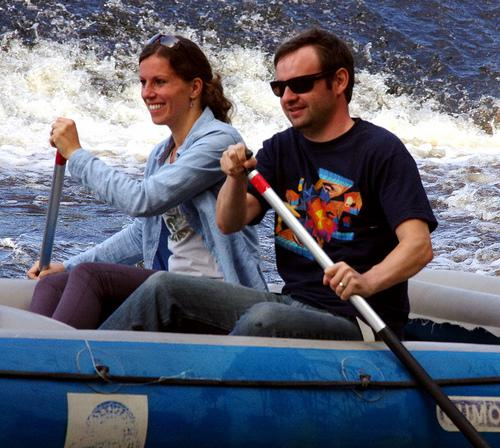Question: what keeps them afloat?
Choices:
A. Gravity.
B. Buoyancy.
C. Determination.
D. A boat.
Answer with the letter. Answer: B Question: what is on his left hand?
Choices:
A. A wedding band.
B. A flower.
C. A tattoo.
D. A bracelet.
Answer with the letter. Answer: A Question: who is wearing sunglasses on the forehead?
Choices:
A. The Boy.
B. The woman.
C. A Cat.
D. The man in the yellow shirt.
Answer with the letter. Answer: B 